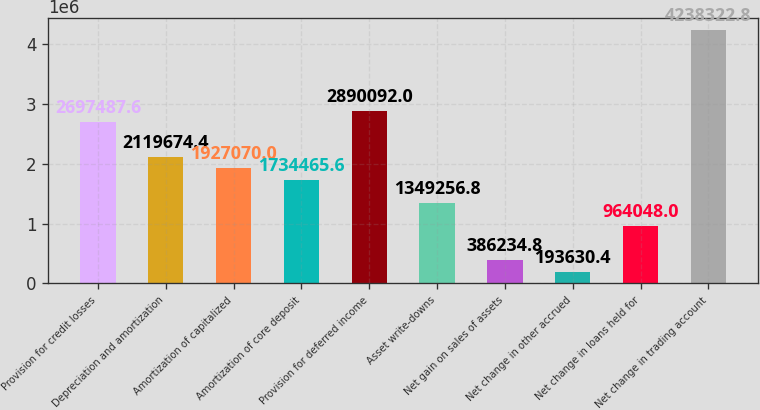Convert chart to OTSL. <chart><loc_0><loc_0><loc_500><loc_500><bar_chart><fcel>Provision for credit losses<fcel>Depreciation and amortization<fcel>Amortization of capitalized<fcel>Amortization of core deposit<fcel>Provision for deferred income<fcel>Asset write-downs<fcel>Net gain on sales of assets<fcel>Net change in other accrued<fcel>Net change in loans held for<fcel>Net change in trading account<nl><fcel>2.69749e+06<fcel>2.11967e+06<fcel>1.92707e+06<fcel>1.73447e+06<fcel>2.89009e+06<fcel>1.34926e+06<fcel>386235<fcel>193630<fcel>964048<fcel>4.23832e+06<nl></chart> 